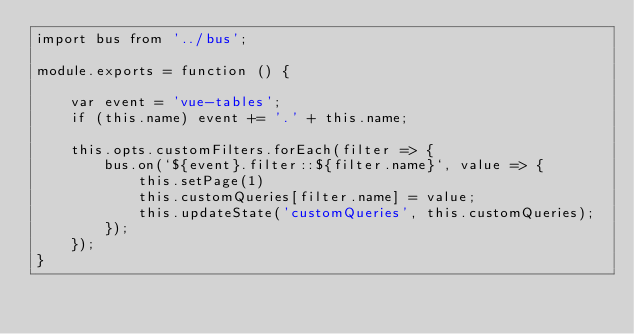Convert code to text. <code><loc_0><loc_0><loc_500><loc_500><_JavaScript_>import bus from '../bus';

module.exports = function () {

    var event = 'vue-tables';
    if (this.name) event += '.' + this.name;

    this.opts.customFilters.forEach(filter => {
        bus.on(`${event}.filter::${filter.name}`, value => {
            this.setPage(1)
            this.customQueries[filter.name] = value;
            this.updateState('customQueries', this.customQueries);
        });
    });
}
</code> 